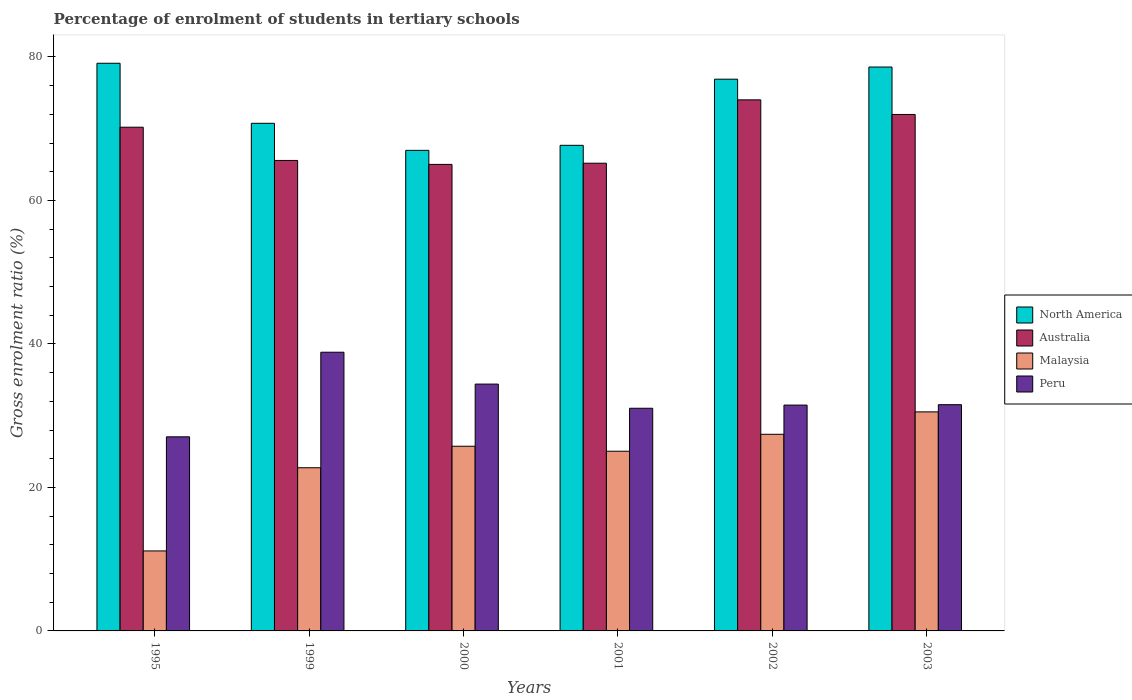How many different coloured bars are there?
Provide a succinct answer. 4. Are the number of bars per tick equal to the number of legend labels?
Offer a very short reply. Yes. Are the number of bars on each tick of the X-axis equal?
Offer a very short reply. Yes. How many bars are there on the 1st tick from the right?
Make the answer very short. 4. What is the label of the 4th group of bars from the left?
Your answer should be compact. 2001. In how many cases, is the number of bars for a given year not equal to the number of legend labels?
Ensure brevity in your answer.  0. What is the percentage of students enrolled in tertiary schools in North America in 1999?
Keep it short and to the point. 70.75. Across all years, what is the maximum percentage of students enrolled in tertiary schools in Australia?
Offer a very short reply. 74.02. Across all years, what is the minimum percentage of students enrolled in tertiary schools in Malaysia?
Provide a short and direct response. 11.15. What is the total percentage of students enrolled in tertiary schools in Malaysia in the graph?
Provide a short and direct response. 142.62. What is the difference between the percentage of students enrolled in tertiary schools in Australia in 1999 and that in 2001?
Offer a terse response. 0.39. What is the difference between the percentage of students enrolled in tertiary schools in Peru in 2001 and the percentage of students enrolled in tertiary schools in North America in 2002?
Ensure brevity in your answer.  -45.87. What is the average percentage of students enrolled in tertiary schools in North America per year?
Make the answer very short. 73.34. In the year 1999, what is the difference between the percentage of students enrolled in tertiary schools in Malaysia and percentage of students enrolled in tertiary schools in North America?
Provide a succinct answer. -48.01. What is the ratio of the percentage of students enrolled in tertiary schools in Peru in 1999 to that in 2000?
Offer a very short reply. 1.13. What is the difference between the highest and the second highest percentage of students enrolled in tertiary schools in Australia?
Offer a terse response. 2.04. What is the difference between the highest and the lowest percentage of students enrolled in tertiary schools in Peru?
Offer a terse response. 11.79. Is the sum of the percentage of students enrolled in tertiary schools in Malaysia in 1995 and 2002 greater than the maximum percentage of students enrolled in tertiary schools in Peru across all years?
Offer a very short reply. No. What does the 2nd bar from the right in 1995 represents?
Keep it short and to the point. Malaysia. Is it the case that in every year, the sum of the percentage of students enrolled in tertiary schools in North America and percentage of students enrolled in tertiary schools in Malaysia is greater than the percentage of students enrolled in tertiary schools in Australia?
Ensure brevity in your answer.  Yes. How many bars are there?
Your response must be concise. 24. Are all the bars in the graph horizontal?
Your response must be concise. No. Does the graph contain any zero values?
Offer a terse response. No. Does the graph contain grids?
Make the answer very short. No. How are the legend labels stacked?
Offer a very short reply. Vertical. What is the title of the graph?
Give a very brief answer. Percentage of enrolment of students in tertiary schools. What is the label or title of the X-axis?
Offer a terse response. Years. What is the Gross enrolment ratio (%) of North America in 1995?
Your answer should be compact. 79.12. What is the Gross enrolment ratio (%) in Australia in 1995?
Your response must be concise. 70.21. What is the Gross enrolment ratio (%) in Malaysia in 1995?
Your answer should be very brief. 11.15. What is the Gross enrolment ratio (%) in Peru in 1995?
Keep it short and to the point. 27.05. What is the Gross enrolment ratio (%) in North America in 1999?
Offer a terse response. 70.75. What is the Gross enrolment ratio (%) of Australia in 1999?
Give a very brief answer. 65.58. What is the Gross enrolment ratio (%) in Malaysia in 1999?
Your answer should be compact. 22.74. What is the Gross enrolment ratio (%) in Peru in 1999?
Keep it short and to the point. 38.85. What is the Gross enrolment ratio (%) of North America in 2000?
Your answer should be very brief. 66.98. What is the Gross enrolment ratio (%) in Australia in 2000?
Your answer should be compact. 65.03. What is the Gross enrolment ratio (%) in Malaysia in 2000?
Provide a short and direct response. 25.74. What is the Gross enrolment ratio (%) of Peru in 2000?
Offer a terse response. 34.41. What is the Gross enrolment ratio (%) in North America in 2001?
Your answer should be compact. 67.68. What is the Gross enrolment ratio (%) of Australia in 2001?
Your answer should be very brief. 65.19. What is the Gross enrolment ratio (%) of Malaysia in 2001?
Ensure brevity in your answer.  25.05. What is the Gross enrolment ratio (%) in Peru in 2001?
Provide a succinct answer. 31.04. What is the Gross enrolment ratio (%) in North America in 2002?
Provide a short and direct response. 76.91. What is the Gross enrolment ratio (%) of Australia in 2002?
Provide a short and direct response. 74.02. What is the Gross enrolment ratio (%) of Malaysia in 2002?
Offer a very short reply. 27.41. What is the Gross enrolment ratio (%) in Peru in 2002?
Your response must be concise. 31.48. What is the Gross enrolment ratio (%) of North America in 2003?
Your answer should be very brief. 78.6. What is the Gross enrolment ratio (%) in Australia in 2003?
Your answer should be very brief. 71.99. What is the Gross enrolment ratio (%) of Malaysia in 2003?
Give a very brief answer. 30.53. What is the Gross enrolment ratio (%) in Peru in 2003?
Your answer should be compact. 31.53. Across all years, what is the maximum Gross enrolment ratio (%) in North America?
Your response must be concise. 79.12. Across all years, what is the maximum Gross enrolment ratio (%) in Australia?
Provide a succinct answer. 74.02. Across all years, what is the maximum Gross enrolment ratio (%) of Malaysia?
Keep it short and to the point. 30.53. Across all years, what is the maximum Gross enrolment ratio (%) in Peru?
Give a very brief answer. 38.85. Across all years, what is the minimum Gross enrolment ratio (%) of North America?
Your response must be concise. 66.98. Across all years, what is the minimum Gross enrolment ratio (%) of Australia?
Keep it short and to the point. 65.03. Across all years, what is the minimum Gross enrolment ratio (%) in Malaysia?
Give a very brief answer. 11.15. Across all years, what is the minimum Gross enrolment ratio (%) in Peru?
Provide a short and direct response. 27.05. What is the total Gross enrolment ratio (%) of North America in the graph?
Provide a short and direct response. 440.05. What is the total Gross enrolment ratio (%) of Australia in the graph?
Make the answer very short. 412.01. What is the total Gross enrolment ratio (%) of Malaysia in the graph?
Your answer should be very brief. 142.62. What is the total Gross enrolment ratio (%) in Peru in the graph?
Offer a terse response. 194.35. What is the difference between the Gross enrolment ratio (%) of North America in 1995 and that in 1999?
Offer a very short reply. 8.37. What is the difference between the Gross enrolment ratio (%) in Australia in 1995 and that in 1999?
Make the answer very short. 4.63. What is the difference between the Gross enrolment ratio (%) in Malaysia in 1995 and that in 1999?
Give a very brief answer. -11.6. What is the difference between the Gross enrolment ratio (%) of Peru in 1995 and that in 1999?
Give a very brief answer. -11.79. What is the difference between the Gross enrolment ratio (%) of North America in 1995 and that in 2000?
Your answer should be compact. 12.14. What is the difference between the Gross enrolment ratio (%) in Australia in 1995 and that in 2000?
Your response must be concise. 5.18. What is the difference between the Gross enrolment ratio (%) in Malaysia in 1995 and that in 2000?
Keep it short and to the point. -14.59. What is the difference between the Gross enrolment ratio (%) of Peru in 1995 and that in 2000?
Offer a terse response. -7.35. What is the difference between the Gross enrolment ratio (%) in North America in 1995 and that in 2001?
Give a very brief answer. 11.44. What is the difference between the Gross enrolment ratio (%) of Australia in 1995 and that in 2001?
Your answer should be compact. 5.02. What is the difference between the Gross enrolment ratio (%) of Malaysia in 1995 and that in 2001?
Your answer should be compact. -13.9. What is the difference between the Gross enrolment ratio (%) of Peru in 1995 and that in 2001?
Make the answer very short. -3.98. What is the difference between the Gross enrolment ratio (%) in North America in 1995 and that in 2002?
Provide a succinct answer. 2.22. What is the difference between the Gross enrolment ratio (%) of Australia in 1995 and that in 2002?
Make the answer very short. -3.81. What is the difference between the Gross enrolment ratio (%) in Malaysia in 1995 and that in 2002?
Provide a short and direct response. -16.26. What is the difference between the Gross enrolment ratio (%) in Peru in 1995 and that in 2002?
Provide a succinct answer. -4.42. What is the difference between the Gross enrolment ratio (%) in North America in 1995 and that in 2003?
Offer a terse response. 0.52. What is the difference between the Gross enrolment ratio (%) of Australia in 1995 and that in 2003?
Offer a terse response. -1.78. What is the difference between the Gross enrolment ratio (%) of Malaysia in 1995 and that in 2003?
Give a very brief answer. -19.38. What is the difference between the Gross enrolment ratio (%) of Peru in 1995 and that in 2003?
Your answer should be very brief. -4.48. What is the difference between the Gross enrolment ratio (%) of North America in 1999 and that in 2000?
Make the answer very short. 3.77. What is the difference between the Gross enrolment ratio (%) of Australia in 1999 and that in 2000?
Offer a terse response. 0.55. What is the difference between the Gross enrolment ratio (%) of Malaysia in 1999 and that in 2000?
Keep it short and to the point. -3. What is the difference between the Gross enrolment ratio (%) of Peru in 1999 and that in 2000?
Provide a succinct answer. 4.44. What is the difference between the Gross enrolment ratio (%) in North America in 1999 and that in 2001?
Make the answer very short. 3.07. What is the difference between the Gross enrolment ratio (%) in Australia in 1999 and that in 2001?
Offer a terse response. 0.39. What is the difference between the Gross enrolment ratio (%) of Malaysia in 1999 and that in 2001?
Provide a succinct answer. -2.3. What is the difference between the Gross enrolment ratio (%) of Peru in 1999 and that in 2001?
Ensure brevity in your answer.  7.81. What is the difference between the Gross enrolment ratio (%) of North America in 1999 and that in 2002?
Keep it short and to the point. -6.15. What is the difference between the Gross enrolment ratio (%) of Australia in 1999 and that in 2002?
Offer a terse response. -8.45. What is the difference between the Gross enrolment ratio (%) of Malaysia in 1999 and that in 2002?
Make the answer very short. -4.66. What is the difference between the Gross enrolment ratio (%) in Peru in 1999 and that in 2002?
Your answer should be very brief. 7.37. What is the difference between the Gross enrolment ratio (%) of North America in 1999 and that in 2003?
Offer a very short reply. -7.85. What is the difference between the Gross enrolment ratio (%) in Australia in 1999 and that in 2003?
Your answer should be compact. -6.41. What is the difference between the Gross enrolment ratio (%) of Malaysia in 1999 and that in 2003?
Your answer should be very brief. -7.79. What is the difference between the Gross enrolment ratio (%) in Peru in 1999 and that in 2003?
Give a very brief answer. 7.31. What is the difference between the Gross enrolment ratio (%) of Australia in 2000 and that in 2001?
Your answer should be very brief. -0.17. What is the difference between the Gross enrolment ratio (%) in Malaysia in 2000 and that in 2001?
Ensure brevity in your answer.  0.7. What is the difference between the Gross enrolment ratio (%) in Peru in 2000 and that in 2001?
Make the answer very short. 3.37. What is the difference between the Gross enrolment ratio (%) in North America in 2000 and that in 2002?
Your response must be concise. -9.92. What is the difference between the Gross enrolment ratio (%) in Australia in 2000 and that in 2002?
Your answer should be very brief. -9. What is the difference between the Gross enrolment ratio (%) in Malaysia in 2000 and that in 2002?
Provide a succinct answer. -1.67. What is the difference between the Gross enrolment ratio (%) of Peru in 2000 and that in 2002?
Give a very brief answer. 2.93. What is the difference between the Gross enrolment ratio (%) in North America in 2000 and that in 2003?
Keep it short and to the point. -11.61. What is the difference between the Gross enrolment ratio (%) in Australia in 2000 and that in 2003?
Ensure brevity in your answer.  -6.96. What is the difference between the Gross enrolment ratio (%) of Malaysia in 2000 and that in 2003?
Your answer should be very brief. -4.79. What is the difference between the Gross enrolment ratio (%) in Peru in 2000 and that in 2003?
Make the answer very short. 2.87. What is the difference between the Gross enrolment ratio (%) in North America in 2001 and that in 2002?
Keep it short and to the point. -9.22. What is the difference between the Gross enrolment ratio (%) in Australia in 2001 and that in 2002?
Provide a succinct answer. -8.83. What is the difference between the Gross enrolment ratio (%) of Malaysia in 2001 and that in 2002?
Offer a terse response. -2.36. What is the difference between the Gross enrolment ratio (%) of Peru in 2001 and that in 2002?
Offer a very short reply. -0.44. What is the difference between the Gross enrolment ratio (%) in North America in 2001 and that in 2003?
Offer a terse response. -10.91. What is the difference between the Gross enrolment ratio (%) of Australia in 2001 and that in 2003?
Offer a terse response. -6.8. What is the difference between the Gross enrolment ratio (%) in Malaysia in 2001 and that in 2003?
Your answer should be compact. -5.48. What is the difference between the Gross enrolment ratio (%) in Peru in 2001 and that in 2003?
Give a very brief answer. -0.5. What is the difference between the Gross enrolment ratio (%) of North America in 2002 and that in 2003?
Your answer should be compact. -1.69. What is the difference between the Gross enrolment ratio (%) of Australia in 2002 and that in 2003?
Give a very brief answer. 2.04. What is the difference between the Gross enrolment ratio (%) of Malaysia in 2002 and that in 2003?
Offer a terse response. -3.12. What is the difference between the Gross enrolment ratio (%) in Peru in 2002 and that in 2003?
Keep it short and to the point. -0.06. What is the difference between the Gross enrolment ratio (%) of North America in 1995 and the Gross enrolment ratio (%) of Australia in 1999?
Keep it short and to the point. 13.55. What is the difference between the Gross enrolment ratio (%) of North America in 1995 and the Gross enrolment ratio (%) of Malaysia in 1999?
Make the answer very short. 56.38. What is the difference between the Gross enrolment ratio (%) of North America in 1995 and the Gross enrolment ratio (%) of Peru in 1999?
Your response must be concise. 40.28. What is the difference between the Gross enrolment ratio (%) in Australia in 1995 and the Gross enrolment ratio (%) in Malaysia in 1999?
Keep it short and to the point. 47.46. What is the difference between the Gross enrolment ratio (%) in Australia in 1995 and the Gross enrolment ratio (%) in Peru in 1999?
Provide a short and direct response. 31.36. What is the difference between the Gross enrolment ratio (%) of Malaysia in 1995 and the Gross enrolment ratio (%) of Peru in 1999?
Offer a terse response. -27.7. What is the difference between the Gross enrolment ratio (%) in North America in 1995 and the Gross enrolment ratio (%) in Australia in 2000?
Offer a very short reply. 14.1. What is the difference between the Gross enrolment ratio (%) of North America in 1995 and the Gross enrolment ratio (%) of Malaysia in 2000?
Make the answer very short. 53.38. What is the difference between the Gross enrolment ratio (%) of North America in 1995 and the Gross enrolment ratio (%) of Peru in 2000?
Your answer should be compact. 44.72. What is the difference between the Gross enrolment ratio (%) in Australia in 1995 and the Gross enrolment ratio (%) in Malaysia in 2000?
Ensure brevity in your answer.  44.47. What is the difference between the Gross enrolment ratio (%) in Australia in 1995 and the Gross enrolment ratio (%) in Peru in 2000?
Ensure brevity in your answer.  35.8. What is the difference between the Gross enrolment ratio (%) in Malaysia in 1995 and the Gross enrolment ratio (%) in Peru in 2000?
Ensure brevity in your answer.  -23.26. What is the difference between the Gross enrolment ratio (%) of North America in 1995 and the Gross enrolment ratio (%) of Australia in 2001?
Ensure brevity in your answer.  13.93. What is the difference between the Gross enrolment ratio (%) in North America in 1995 and the Gross enrolment ratio (%) in Malaysia in 2001?
Your answer should be compact. 54.08. What is the difference between the Gross enrolment ratio (%) in North America in 1995 and the Gross enrolment ratio (%) in Peru in 2001?
Offer a very short reply. 48.09. What is the difference between the Gross enrolment ratio (%) in Australia in 1995 and the Gross enrolment ratio (%) in Malaysia in 2001?
Offer a terse response. 45.16. What is the difference between the Gross enrolment ratio (%) of Australia in 1995 and the Gross enrolment ratio (%) of Peru in 2001?
Offer a very short reply. 39.17. What is the difference between the Gross enrolment ratio (%) in Malaysia in 1995 and the Gross enrolment ratio (%) in Peru in 2001?
Your answer should be very brief. -19.89. What is the difference between the Gross enrolment ratio (%) in North America in 1995 and the Gross enrolment ratio (%) in Malaysia in 2002?
Keep it short and to the point. 51.72. What is the difference between the Gross enrolment ratio (%) of North America in 1995 and the Gross enrolment ratio (%) of Peru in 2002?
Offer a terse response. 47.65. What is the difference between the Gross enrolment ratio (%) of Australia in 1995 and the Gross enrolment ratio (%) of Malaysia in 2002?
Ensure brevity in your answer.  42.8. What is the difference between the Gross enrolment ratio (%) in Australia in 1995 and the Gross enrolment ratio (%) in Peru in 2002?
Give a very brief answer. 38.73. What is the difference between the Gross enrolment ratio (%) in Malaysia in 1995 and the Gross enrolment ratio (%) in Peru in 2002?
Ensure brevity in your answer.  -20.33. What is the difference between the Gross enrolment ratio (%) in North America in 1995 and the Gross enrolment ratio (%) in Australia in 2003?
Give a very brief answer. 7.14. What is the difference between the Gross enrolment ratio (%) of North America in 1995 and the Gross enrolment ratio (%) of Malaysia in 2003?
Provide a succinct answer. 48.59. What is the difference between the Gross enrolment ratio (%) of North America in 1995 and the Gross enrolment ratio (%) of Peru in 2003?
Provide a succinct answer. 47.59. What is the difference between the Gross enrolment ratio (%) of Australia in 1995 and the Gross enrolment ratio (%) of Malaysia in 2003?
Keep it short and to the point. 39.68. What is the difference between the Gross enrolment ratio (%) of Australia in 1995 and the Gross enrolment ratio (%) of Peru in 2003?
Provide a succinct answer. 38.67. What is the difference between the Gross enrolment ratio (%) of Malaysia in 1995 and the Gross enrolment ratio (%) of Peru in 2003?
Provide a succinct answer. -20.38. What is the difference between the Gross enrolment ratio (%) in North America in 1999 and the Gross enrolment ratio (%) in Australia in 2000?
Ensure brevity in your answer.  5.73. What is the difference between the Gross enrolment ratio (%) in North America in 1999 and the Gross enrolment ratio (%) in Malaysia in 2000?
Your answer should be very brief. 45.01. What is the difference between the Gross enrolment ratio (%) in North America in 1999 and the Gross enrolment ratio (%) in Peru in 2000?
Provide a succinct answer. 36.35. What is the difference between the Gross enrolment ratio (%) of Australia in 1999 and the Gross enrolment ratio (%) of Malaysia in 2000?
Provide a succinct answer. 39.83. What is the difference between the Gross enrolment ratio (%) of Australia in 1999 and the Gross enrolment ratio (%) of Peru in 2000?
Provide a short and direct response. 31.17. What is the difference between the Gross enrolment ratio (%) of Malaysia in 1999 and the Gross enrolment ratio (%) of Peru in 2000?
Your answer should be compact. -11.66. What is the difference between the Gross enrolment ratio (%) of North America in 1999 and the Gross enrolment ratio (%) of Australia in 2001?
Make the answer very short. 5.56. What is the difference between the Gross enrolment ratio (%) of North America in 1999 and the Gross enrolment ratio (%) of Malaysia in 2001?
Give a very brief answer. 45.71. What is the difference between the Gross enrolment ratio (%) in North America in 1999 and the Gross enrolment ratio (%) in Peru in 2001?
Make the answer very short. 39.72. What is the difference between the Gross enrolment ratio (%) in Australia in 1999 and the Gross enrolment ratio (%) in Malaysia in 2001?
Provide a succinct answer. 40.53. What is the difference between the Gross enrolment ratio (%) in Australia in 1999 and the Gross enrolment ratio (%) in Peru in 2001?
Keep it short and to the point. 34.54. What is the difference between the Gross enrolment ratio (%) of Malaysia in 1999 and the Gross enrolment ratio (%) of Peru in 2001?
Keep it short and to the point. -8.29. What is the difference between the Gross enrolment ratio (%) of North America in 1999 and the Gross enrolment ratio (%) of Australia in 2002?
Provide a short and direct response. -3.27. What is the difference between the Gross enrolment ratio (%) of North America in 1999 and the Gross enrolment ratio (%) of Malaysia in 2002?
Your answer should be very brief. 43.34. What is the difference between the Gross enrolment ratio (%) in North America in 1999 and the Gross enrolment ratio (%) in Peru in 2002?
Provide a succinct answer. 39.28. What is the difference between the Gross enrolment ratio (%) of Australia in 1999 and the Gross enrolment ratio (%) of Malaysia in 2002?
Ensure brevity in your answer.  38.17. What is the difference between the Gross enrolment ratio (%) in Australia in 1999 and the Gross enrolment ratio (%) in Peru in 2002?
Offer a terse response. 34.1. What is the difference between the Gross enrolment ratio (%) in Malaysia in 1999 and the Gross enrolment ratio (%) in Peru in 2002?
Ensure brevity in your answer.  -8.73. What is the difference between the Gross enrolment ratio (%) in North America in 1999 and the Gross enrolment ratio (%) in Australia in 2003?
Your answer should be very brief. -1.23. What is the difference between the Gross enrolment ratio (%) in North America in 1999 and the Gross enrolment ratio (%) in Malaysia in 2003?
Ensure brevity in your answer.  40.22. What is the difference between the Gross enrolment ratio (%) in North America in 1999 and the Gross enrolment ratio (%) in Peru in 2003?
Provide a short and direct response. 39.22. What is the difference between the Gross enrolment ratio (%) of Australia in 1999 and the Gross enrolment ratio (%) of Malaysia in 2003?
Your answer should be compact. 35.05. What is the difference between the Gross enrolment ratio (%) in Australia in 1999 and the Gross enrolment ratio (%) in Peru in 2003?
Offer a terse response. 34.04. What is the difference between the Gross enrolment ratio (%) of Malaysia in 1999 and the Gross enrolment ratio (%) of Peru in 2003?
Your response must be concise. -8.79. What is the difference between the Gross enrolment ratio (%) of North America in 2000 and the Gross enrolment ratio (%) of Australia in 2001?
Ensure brevity in your answer.  1.79. What is the difference between the Gross enrolment ratio (%) in North America in 2000 and the Gross enrolment ratio (%) in Malaysia in 2001?
Your response must be concise. 41.94. What is the difference between the Gross enrolment ratio (%) of North America in 2000 and the Gross enrolment ratio (%) of Peru in 2001?
Your answer should be compact. 35.95. What is the difference between the Gross enrolment ratio (%) of Australia in 2000 and the Gross enrolment ratio (%) of Malaysia in 2001?
Offer a terse response. 39.98. What is the difference between the Gross enrolment ratio (%) of Australia in 2000 and the Gross enrolment ratio (%) of Peru in 2001?
Offer a terse response. 33.99. What is the difference between the Gross enrolment ratio (%) in Malaysia in 2000 and the Gross enrolment ratio (%) in Peru in 2001?
Your answer should be compact. -5.29. What is the difference between the Gross enrolment ratio (%) in North America in 2000 and the Gross enrolment ratio (%) in Australia in 2002?
Your answer should be compact. -7.04. What is the difference between the Gross enrolment ratio (%) of North America in 2000 and the Gross enrolment ratio (%) of Malaysia in 2002?
Your response must be concise. 39.58. What is the difference between the Gross enrolment ratio (%) of North America in 2000 and the Gross enrolment ratio (%) of Peru in 2002?
Provide a succinct answer. 35.51. What is the difference between the Gross enrolment ratio (%) of Australia in 2000 and the Gross enrolment ratio (%) of Malaysia in 2002?
Your answer should be very brief. 37.62. What is the difference between the Gross enrolment ratio (%) in Australia in 2000 and the Gross enrolment ratio (%) in Peru in 2002?
Provide a succinct answer. 33.55. What is the difference between the Gross enrolment ratio (%) in Malaysia in 2000 and the Gross enrolment ratio (%) in Peru in 2002?
Offer a very short reply. -5.74. What is the difference between the Gross enrolment ratio (%) in North America in 2000 and the Gross enrolment ratio (%) in Australia in 2003?
Ensure brevity in your answer.  -5. What is the difference between the Gross enrolment ratio (%) in North America in 2000 and the Gross enrolment ratio (%) in Malaysia in 2003?
Offer a terse response. 36.45. What is the difference between the Gross enrolment ratio (%) in North America in 2000 and the Gross enrolment ratio (%) in Peru in 2003?
Your response must be concise. 35.45. What is the difference between the Gross enrolment ratio (%) of Australia in 2000 and the Gross enrolment ratio (%) of Malaysia in 2003?
Your answer should be compact. 34.5. What is the difference between the Gross enrolment ratio (%) in Australia in 2000 and the Gross enrolment ratio (%) in Peru in 2003?
Make the answer very short. 33.49. What is the difference between the Gross enrolment ratio (%) in Malaysia in 2000 and the Gross enrolment ratio (%) in Peru in 2003?
Your answer should be compact. -5.79. What is the difference between the Gross enrolment ratio (%) of North America in 2001 and the Gross enrolment ratio (%) of Australia in 2002?
Provide a succinct answer. -6.34. What is the difference between the Gross enrolment ratio (%) in North America in 2001 and the Gross enrolment ratio (%) in Malaysia in 2002?
Keep it short and to the point. 40.28. What is the difference between the Gross enrolment ratio (%) of North America in 2001 and the Gross enrolment ratio (%) of Peru in 2002?
Provide a short and direct response. 36.21. What is the difference between the Gross enrolment ratio (%) in Australia in 2001 and the Gross enrolment ratio (%) in Malaysia in 2002?
Provide a succinct answer. 37.78. What is the difference between the Gross enrolment ratio (%) in Australia in 2001 and the Gross enrolment ratio (%) in Peru in 2002?
Provide a succinct answer. 33.71. What is the difference between the Gross enrolment ratio (%) in Malaysia in 2001 and the Gross enrolment ratio (%) in Peru in 2002?
Give a very brief answer. -6.43. What is the difference between the Gross enrolment ratio (%) of North America in 2001 and the Gross enrolment ratio (%) of Australia in 2003?
Your answer should be compact. -4.3. What is the difference between the Gross enrolment ratio (%) of North America in 2001 and the Gross enrolment ratio (%) of Malaysia in 2003?
Your answer should be very brief. 37.15. What is the difference between the Gross enrolment ratio (%) of North America in 2001 and the Gross enrolment ratio (%) of Peru in 2003?
Provide a short and direct response. 36.15. What is the difference between the Gross enrolment ratio (%) of Australia in 2001 and the Gross enrolment ratio (%) of Malaysia in 2003?
Keep it short and to the point. 34.66. What is the difference between the Gross enrolment ratio (%) in Australia in 2001 and the Gross enrolment ratio (%) in Peru in 2003?
Offer a terse response. 33.66. What is the difference between the Gross enrolment ratio (%) of Malaysia in 2001 and the Gross enrolment ratio (%) of Peru in 2003?
Offer a very short reply. -6.49. What is the difference between the Gross enrolment ratio (%) of North America in 2002 and the Gross enrolment ratio (%) of Australia in 2003?
Give a very brief answer. 4.92. What is the difference between the Gross enrolment ratio (%) in North America in 2002 and the Gross enrolment ratio (%) in Malaysia in 2003?
Ensure brevity in your answer.  46.38. What is the difference between the Gross enrolment ratio (%) in North America in 2002 and the Gross enrolment ratio (%) in Peru in 2003?
Ensure brevity in your answer.  45.37. What is the difference between the Gross enrolment ratio (%) in Australia in 2002 and the Gross enrolment ratio (%) in Malaysia in 2003?
Ensure brevity in your answer.  43.49. What is the difference between the Gross enrolment ratio (%) of Australia in 2002 and the Gross enrolment ratio (%) of Peru in 2003?
Provide a succinct answer. 42.49. What is the difference between the Gross enrolment ratio (%) of Malaysia in 2002 and the Gross enrolment ratio (%) of Peru in 2003?
Your answer should be compact. -4.12. What is the average Gross enrolment ratio (%) of North America per year?
Offer a very short reply. 73.34. What is the average Gross enrolment ratio (%) of Australia per year?
Ensure brevity in your answer.  68.67. What is the average Gross enrolment ratio (%) of Malaysia per year?
Your answer should be compact. 23.77. What is the average Gross enrolment ratio (%) in Peru per year?
Provide a short and direct response. 32.39. In the year 1995, what is the difference between the Gross enrolment ratio (%) of North America and Gross enrolment ratio (%) of Australia?
Your response must be concise. 8.91. In the year 1995, what is the difference between the Gross enrolment ratio (%) in North America and Gross enrolment ratio (%) in Malaysia?
Your answer should be compact. 67.97. In the year 1995, what is the difference between the Gross enrolment ratio (%) in North America and Gross enrolment ratio (%) in Peru?
Your answer should be compact. 52.07. In the year 1995, what is the difference between the Gross enrolment ratio (%) of Australia and Gross enrolment ratio (%) of Malaysia?
Offer a very short reply. 59.06. In the year 1995, what is the difference between the Gross enrolment ratio (%) of Australia and Gross enrolment ratio (%) of Peru?
Your answer should be compact. 43.15. In the year 1995, what is the difference between the Gross enrolment ratio (%) in Malaysia and Gross enrolment ratio (%) in Peru?
Your answer should be very brief. -15.9. In the year 1999, what is the difference between the Gross enrolment ratio (%) of North America and Gross enrolment ratio (%) of Australia?
Keep it short and to the point. 5.18. In the year 1999, what is the difference between the Gross enrolment ratio (%) of North America and Gross enrolment ratio (%) of Malaysia?
Offer a terse response. 48.01. In the year 1999, what is the difference between the Gross enrolment ratio (%) of North America and Gross enrolment ratio (%) of Peru?
Offer a very short reply. 31.91. In the year 1999, what is the difference between the Gross enrolment ratio (%) of Australia and Gross enrolment ratio (%) of Malaysia?
Offer a very short reply. 42.83. In the year 1999, what is the difference between the Gross enrolment ratio (%) of Australia and Gross enrolment ratio (%) of Peru?
Provide a short and direct response. 26.73. In the year 1999, what is the difference between the Gross enrolment ratio (%) of Malaysia and Gross enrolment ratio (%) of Peru?
Make the answer very short. -16.1. In the year 2000, what is the difference between the Gross enrolment ratio (%) of North America and Gross enrolment ratio (%) of Australia?
Offer a terse response. 1.96. In the year 2000, what is the difference between the Gross enrolment ratio (%) of North America and Gross enrolment ratio (%) of Malaysia?
Make the answer very short. 41.24. In the year 2000, what is the difference between the Gross enrolment ratio (%) in North America and Gross enrolment ratio (%) in Peru?
Your answer should be compact. 32.58. In the year 2000, what is the difference between the Gross enrolment ratio (%) of Australia and Gross enrolment ratio (%) of Malaysia?
Keep it short and to the point. 39.28. In the year 2000, what is the difference between the Gross enrolment ratio (%) in Australia and Gross enrolment ratio (%) in Peru?
Your response must be concise. 30.62. In the year 2000, what is the difference between the Gross enrolment ratio (%) in Malaysia and Gross enrolment ratio (%) in Peru?
Your response must be concise. -8.66. In the year 2001, what is the difference between the Gross enrolment ratio (%) in North America and Gross enrolment ratio (%) in Australia?
Keep it short and to the point. 2.49. In the year 2001, what is the difference between the Gross enrolment ratio (%) of North America and Gross enrolment ratio (%) of Malaysia?
Offer a very short reply. 42.64. In the year 2001, what is the difference between the Gross enrolment ratio (%) in North America and Gross enrolment ratio (%) in Peru?
Keep it short and to the point. 36.65. In the year 2001, what is the difference between the Gross enrolment ratio (%) in Australia and Gross enrolment ratio (%) in Malaysia?
Your answer should be very brief. 40.14. In the year 2001, what is the difference between the Gross enrolment ratio (%) in Australia and Gross enrolment ratio (%) in Peru?
Ensure brevity in your answer.  34.16. In the year 2001, what is the difference between the Gross enrolment ratio (%) in Malaysia and Gross enrolment ratio (%) in Peru?
Provide a short and direct response. -5.99. In the year 2002, what is the difference between the Gross enrolment ratio (%) in North America and Gross enrolment ratio (%) in Australia?
Offer a terse response. 2.88. In the year 2002, what is the difference between the Gross enrolment ratio (%) of North America and Gross enrolment ratio (%) of Malaysia?
Keep it short and to the point. 49.5. In the year 2002, what is the difference between the Gross enrolment ratio (%) of North America and Gross enrolment ratio (%) of Peru?
Offer a very short reply. 45.43. In the year 2002, what is the difference between the Gross enrolment ratio (%) of Australia and Gross enrolment ratio (%) of Malaysia?
Offer a very short reply. 46.62. In the year 2002, what is the difference between the Gross enrolment ratio (%) of Australia and Gross enrolment ratio (%) of Peru?
Ensure brevity in your answer.  42.55. In the year 2002, what is the difference between the Gross enrolment ratio (%) of Malaysia and Gross enrolment ratio (%) of Peru?
Your answer should be very brief. -4.07. In the year 2003, what is the difference between the Gross enrolment ratio (%) in North America and Gross enrolment ratio (%) in Australia?
Your answer should be very brief. 6.61. In the year 2003, what is the difference between the Gross enrolment ratio (%) of North America and Gross enrolment ratio (%) of Malaysia?
Provide a short and direct response. 48.07. In the year 2003, what is the difference between the Gross enrolment ratio (%) in North America and Gross enrolment ratio (%) in Peru?
Provide a succinct answer. 47.07. In the year 2003, what is the difference between the Gross enrolment ratio (%) of Australia and Gross enrolment ratio (%) of Malaysia?
Your answer should be very brief. 41.46. In the year 2003, what is the difference between the Gross enrolment ratio (%) in Australia and Gross enrolment ratio (%) in Peru?
Provide a succinct answer. 40.45. In the year 2003, what is the difference between the Gross enrolment ratio (%) in Malaysia and Gross enrolment ratio (%) in Peru?
Offer a very short reply. -1. What is the ratio of the Gross enrolment ratio (%) of North America in 1995 to that in 1999?
Give a very brief answer. 1.12. What is the ratio of the Gross enrolment ratio (%) of Australia in 1995 to that in 1999?
Your answer should be compact. 1.07. What is the ratio of the Gross enrolment ratio (%) of Malaysia in 1995 to that in 1999?
Your response must be concise. 0.49. What is the ratio of the Gross enrolment ratio (%) in Peru in 1995 to that in 1999?
Ensure brevity in your answer.  0.7. What is the ratio of the Gross enrolment ratio (%) of North America in 1995 to that in 2000?
Give a very brief answer. 1.18. What is the ratio of the Gross enrolment ratio (%) of Australia in 1995 to that in 2000?
Your response must be concise. 1.08. What is the ratio of the Gross enrolment ratio (%) of Malaysia in 1995 to that in 2000?
Make the answer very short. 0.43. What is the ratio of the Gross enrolment ratio (%) in Peru in 1995 to that in 2000?
Keep it short and to the point. 0.79. What is the ratio of the Gross enrolment ratio (%) in North America in 1995 to that in 2001?
Ensure brevity in your answer.  1.17. What is the ratio of the Gross enrolment ratio (%) in Australia in 1995 to that in 2001?
Keep it short and to the point. 1.08. What is the ratio of the Gross enrolment ratio (%) of Malaysia in 1995 to that in 2001?
Keep it short and to the point. 0.45. What is the ratio of the Gross enrolment ratio (%) in Peru in 1995 to that in 2001?
Your answer should be very brief. 0.87. What is the ratio of the Gross enrolment ratio (%) in North America in 1995 to that in 2002?
Offer a very short reply. 1.03. What is the ratio of the Gross enrolment ratio (%) of Australia in 1995 to that in 2002?
Provide a succinct answer. 0.95. What is the ratio of the Gross enrolment ratio (%) of Malaysia in 1995 to that in 2002?
Provide a succinct answer. 0.41. What is the ratio of the Gross enrolment ratio (%) in Peru in 1995 to that in 2002?
Offer a very short reply. 0.86. What is the ratio of the Gross enrolment ratio (%) of North America in 1995 to that in 2003?
Provide a short and direct response. 1.01. What is the ratio of the Gross enrolment ratio (%) of Australia in 1995 to that in 2003?
Your response must be concise. 0.98. What is the ratio of the Gross enrolment ratio (%) of Malaysia in 1995 to that in 2003?
Provide a succinct answer. 0.37. What is the ratio of the Gross enrolment ratio (%) of Peru in 1995 to that in 2003?
Keep it short and to the point. 0.86. What is the ratio of the Gross enrolment ratio (%) of North America in 1999 to that in 2000?
Offer a very short reply. 1.06. What is the ratio of the Gross enrolment ratio (%) in Australia in 1999 to that in 2000?
Ensure brevity in your answer.  1.01. What is the ratio of the Gross enrolment ratio (%) of Malaysia in 1999 to that in 2000?
Provide a short and direct response. 0.88. What is the ratio of the Gross enrolment ratio (%) in Peru in 1999 to that in 2000?
Keep it short and to the point. 1.13. What is the ratio of the Gross enrolment ratio (%) in North America in 1999 to that in 2001?
Your answer should be compact. 1.05. What is the ratio of the Gross enrolment ratio (%) of Australia in 1999 to that in 2001?
Provide a succinct answer. 1.01. What is the ratio of the Gross enrolment ratio (%) in Malaysia in 1999 to that in 2001?
Provide a succinct answer. 0.91. What is the ratio of the Gross enrolment ratio (%) of Peru in 1999 to that in 2001?
Ensure brevity in your answer.  1.25. What is the ratio of the Gross enrolment ratio (%) in North America in 1999 to that in 2002?
Your answer should be compact. 0.92. What is the ratio of the Gross enrolment ratio (%) of Australia in 1999 to that in 2002?
Your answer should be compact. 0.89. What is the ratio of the Gross enrolment ratio (%) of Malaysia in 1999 to that in 2002?
Make the answer very short. 0.83. What is the ratio of the Gross enrolment ratio (%) in Peru in 1999 to that in 2002?
Give a very brief answer. 1.23. What is the ratio of the Gross enrolment ratio (%) of North America in 1999 to that in 2003?
Your answer should be very brief. 0.9. What is the ratio of the Gross enrolment ratio (%) of Australia in 1999 to that in 2003?
Offer a very short reply. 0.91. What is the ratio of the Gross enrolment ratio (%) of Malaysia in 1999 to that in 2003?
Offer a terse response. 0.74. What is the ratio of the Gross enrolment ratio (%) of Peru in 1999 to that in 2003?
Your answer should be compact. 1.23. What is the ratio of the Gross enrolment ratio (%) of Malaysia in 2000 to that in 2001?
Ensure brevity in your answer.  1.03. What is the ratio of the Gross enrolment ratio (%) of Peru in 2000 to that in 2001?
Give a very brief answer. 1.11. What is the ratio of the Gross enrolment ratio (%) of North America in 2000 to that in 2002?
Provide a succinct answer. 0.87. What is the ratio of the Gross enrolment ratio (%) of Australia in 2000 to that in 2002?
Your answer should be compact. 0.88. What is the ratio of the Gross enrolment ratio (%) of Malaysia in 2000 to that in 2002?
Your response must be concise. 0.94. What is the ratio of the Gross enrolment ratio (%) of Peru in 2000 to that in 2002?
Keep it short and to the point. 1.09. What is the ratio of the Gross enrolment ratio (%) in North America in 2000 to that in 2003?
Make the answer very short. 0.85. What is the ratio of the Gross enrolment ratio (%) of Australia in 2000 to that in 2003?
Your answer should be compact. 0.9. What is the ratio of the Gross enrolment ratio (%) of Malaysia in 2000 to that in 2003?
Your answer should be compact. 0.84. What is the ratio of the Gross enrolment ratio (%) of Peru in 2000 to that in 2003?
Your response must be concise. 1.09. What is the ratio of the Gross enrolment ratio (%) of North America in 2001 to that in 2002?
Make the answer very short. 0.88. What is the ratio of the Gross enrolment ratio (%) in Australia in 2001 to that in 2002?
Your answer should be compact. 0.88. What is the ratio of the Gross enrolment ratio (%) of Malaysia in 2001 to that in 2002?
Provide a short and direct response. 0.91. What is the ratio of the Gross enrolment ratio (%) of Peru in 2001 to that in 2002?
Your answer should be compact. 0.99. What is the ratio of the Gross enrolment ratio (%) of North America in 2001 to that in 2003?
Your answer should be very brief. 0.86. What is the ratio of the Gross enrolment ratio (%) in Australia in 2001 to that in 2003?
Offer a very short reply. 0.91. What is the ratio of the Gross enrolment ratio (%) of Malaysia in 2001 to that in 2003?
Provide a short and direct response. 0.82. What is the ratio of the Gross enrolment ratio (%) in Peru in 2001 to that in 2003?
Your answer should be very brief. 0.98. What is the ratio of the Gross enrolment ratio (%) in North America in 2002 to that in 2003?
Your answer should be very brief. 0.98. What is the ratio of the Gross enrolment ratio (%) of Australia in 2002 to that in 2003?
Your response must be concise. 1.03. What is the ratio of the Gross enrolment ratio (%) of Malaysia in 2002 to that in 2003?
Ensure brevity in your answer.  0.9. What is the ratio of the Gross enrolment ratio (%) in Peru in 2002 to that in 2003?
Offer a very short reply. 1. What is the difference between the highest and the second highest Gross enrolment ratio (%) in North America?
Offer a terse response. 0.52. What is the difference between the highest and the second highest Gross enrolment ratio (%) of Australia?
Provide a succinct answer. 2.04. What is the difference between the highest and the second highest Gross enrolment ratio (%) of Malaysia?
Provide a short and direct response. 3.12. What is the difference between the highest and the second highest Gross enrolment ratio (%) of Peru?
Your answer should be very brief. 4.44. What is the difference between the highest and the lowest Gross enrolment ratio (%) of North America?
Ensure brevity in your answer.  12.14. What is the difference between the highest and the lowest Gross enrolment ratio (%) of Australia?
Offer a very short reply. 9. What is the difference between the highest and the lowest Gross enrolment ratio (%) in Malaysia?
Offer a terse response. 19.38. What is the difference between the highest and the lowest Gross enrolment ratio (%) of Peru?
Provide a succinct answer. 11.79. 